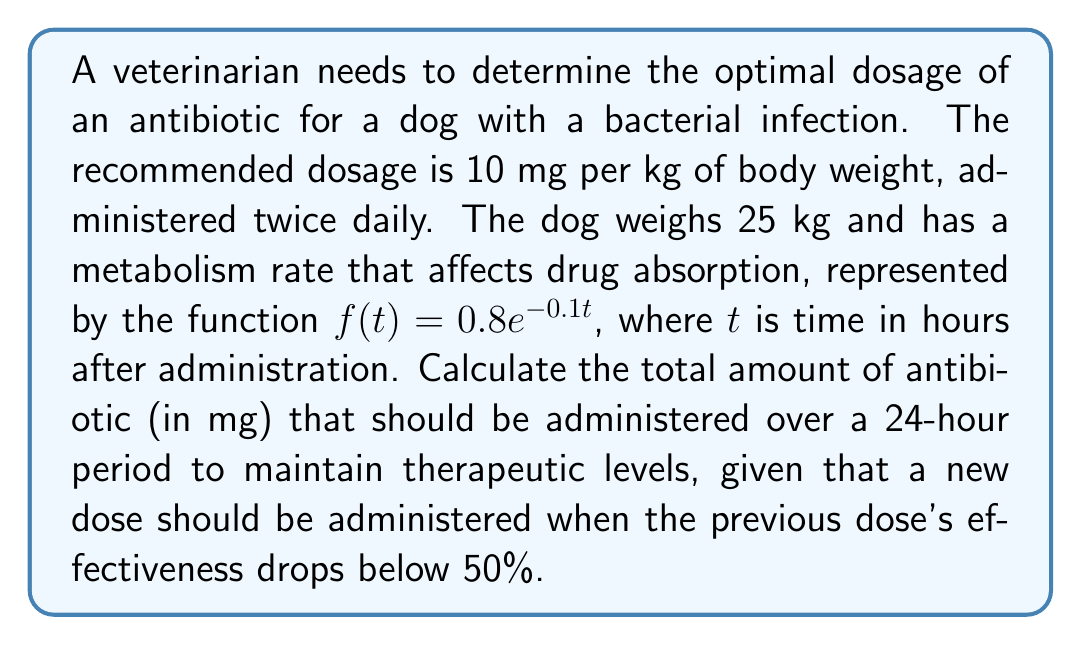Could you help me with this problem? 1) First, calculate the single dose based on the dog's weight:
   Dose = 10 mg/kg × 25 kg = 250 mg

2) Now, we need to determine when the drug's effectiveness drops below 50%:
   $f(t) = 0.8e^{-0.1t} = 0.5$
   $0.8e^{-0.1t} = 0.5$
   $e^{-0.1t} = 0.625$
   $-0.1t = \ln(0.625)$
   $t = -\frac{\ln(0.625)}{0.1} \approx 4.7$ hours

3) This means a new dose should be administered every 4.7 hours.

4) In a 24-hour period, the number of doses will be:
   $\text{Number of doses} = \frac{24 \text{ hours}}{4.7 \text{ hours/dose}} \approx 5.1$

5) Rounding up to ensure therapeutic levels are maintained, we should administer 6 doses in 24 hours.

6) Total amount of antibiotic in 24 hours:
   Total = 6 × 250 mg = 1500 mg
Answer: 1500 mg 